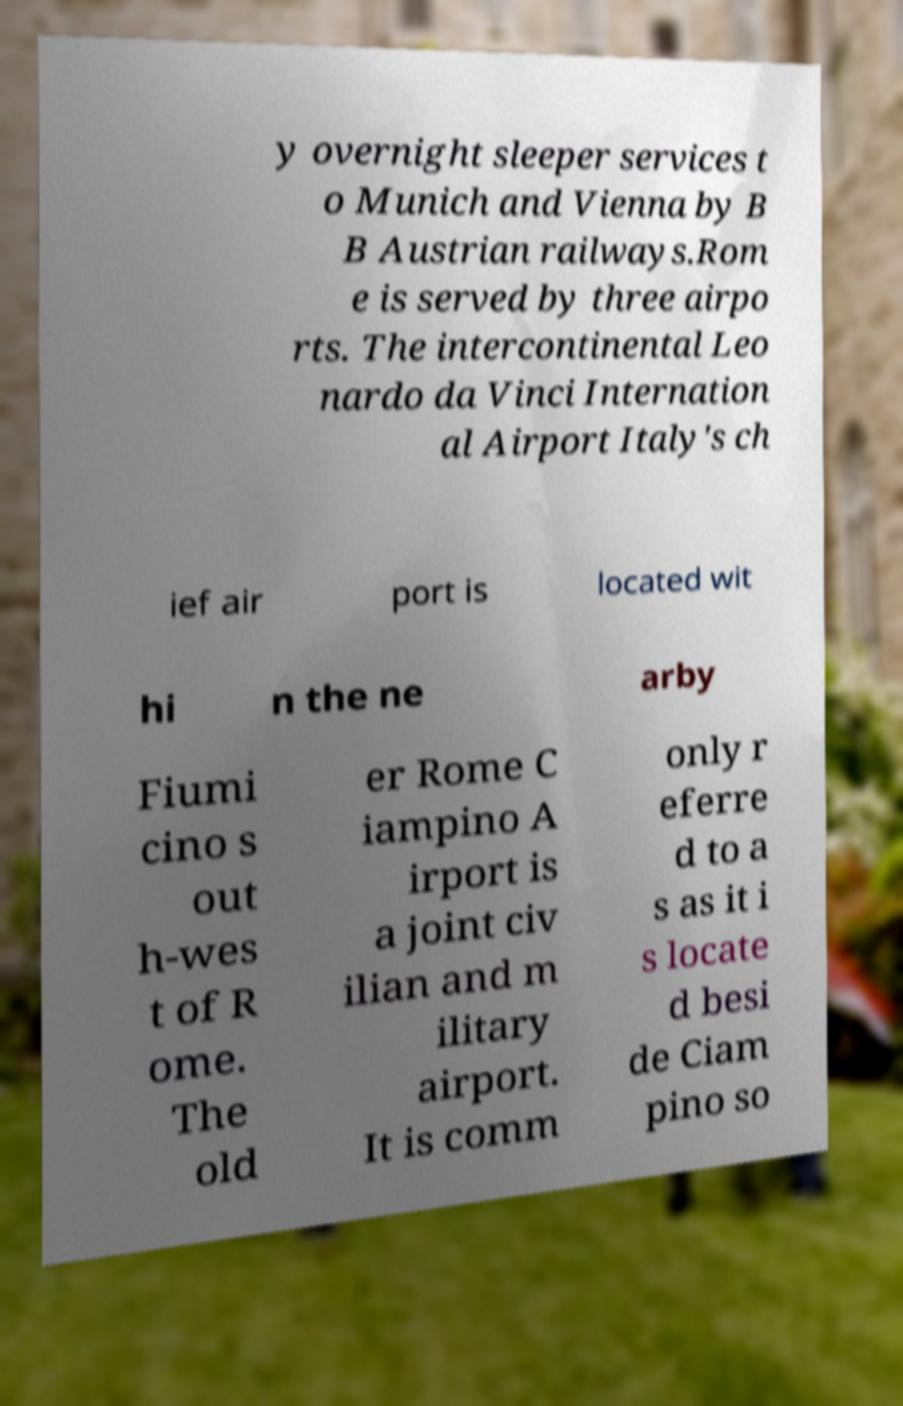Could you assist in decoding the text presented in this image and type it out clearly? y overnight sleeper services t o Munich and Vienna by B B Austrian railways.Rom e is served by three airpo rts. The intercontinental Leo nardo da Vinci Internation al Airport Italy's ch ief air port is located wit hi n the ne arby Fiumi cino s out h-wes t of R ome. The old er Rome C iampino A irport is a joint civ ilian and m ilitary airport. It is comm only r eferre d to a s as it i s locate d besi de Ciam pino so 